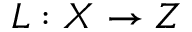<formula> <loc_0><loc_0><loc_500><loc_500>L \colon X \to Z</formula> 